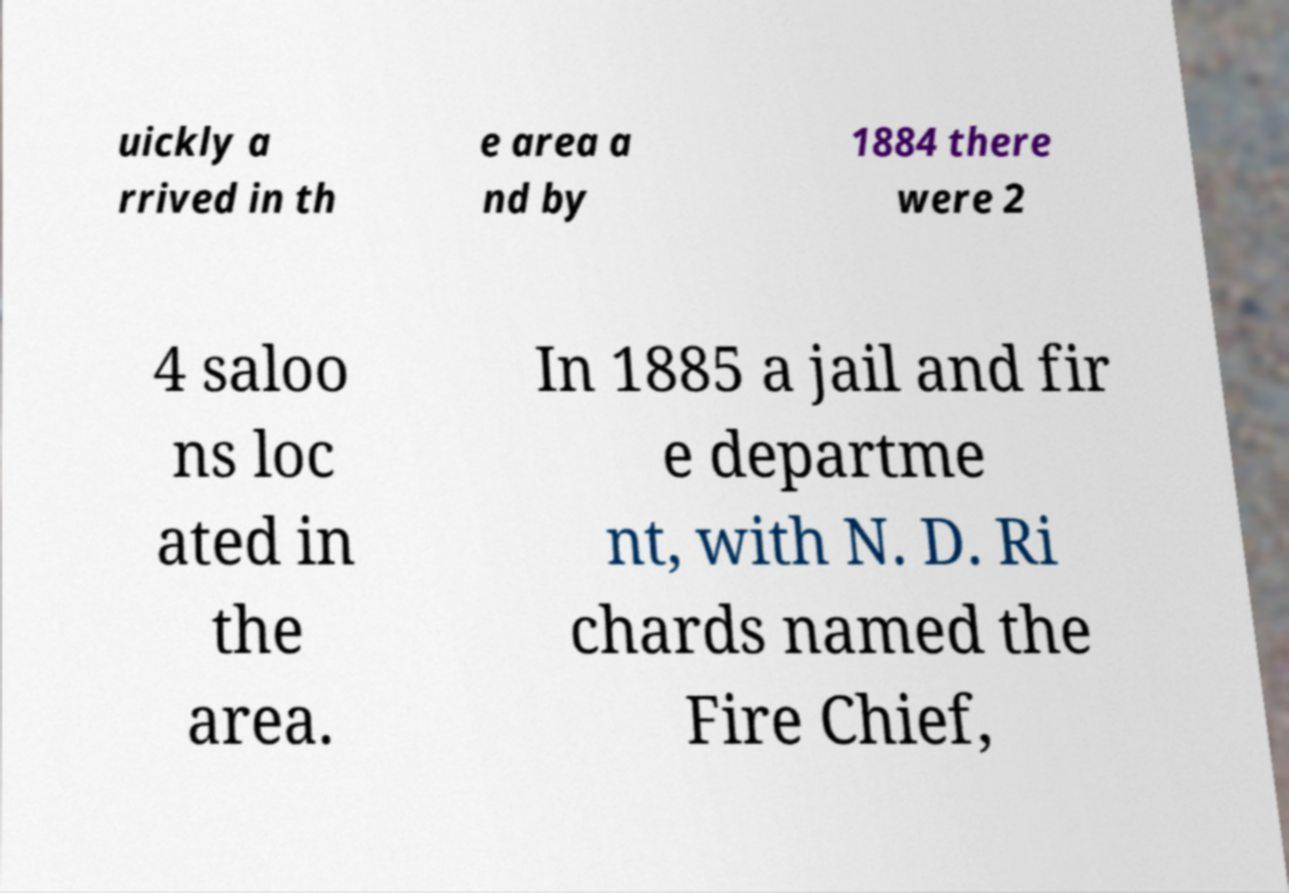Can you read and provide the text displayed in the image?This photo seems to have some interesting text. Can you extract and type it out for me? uickly a rrived in th e area a nd by 1884 there were 2 4 saloo ns loc ated in the area. In 1885 a jail and fir e departme nt, with N. D. Ri chards named the Fire Chief, 